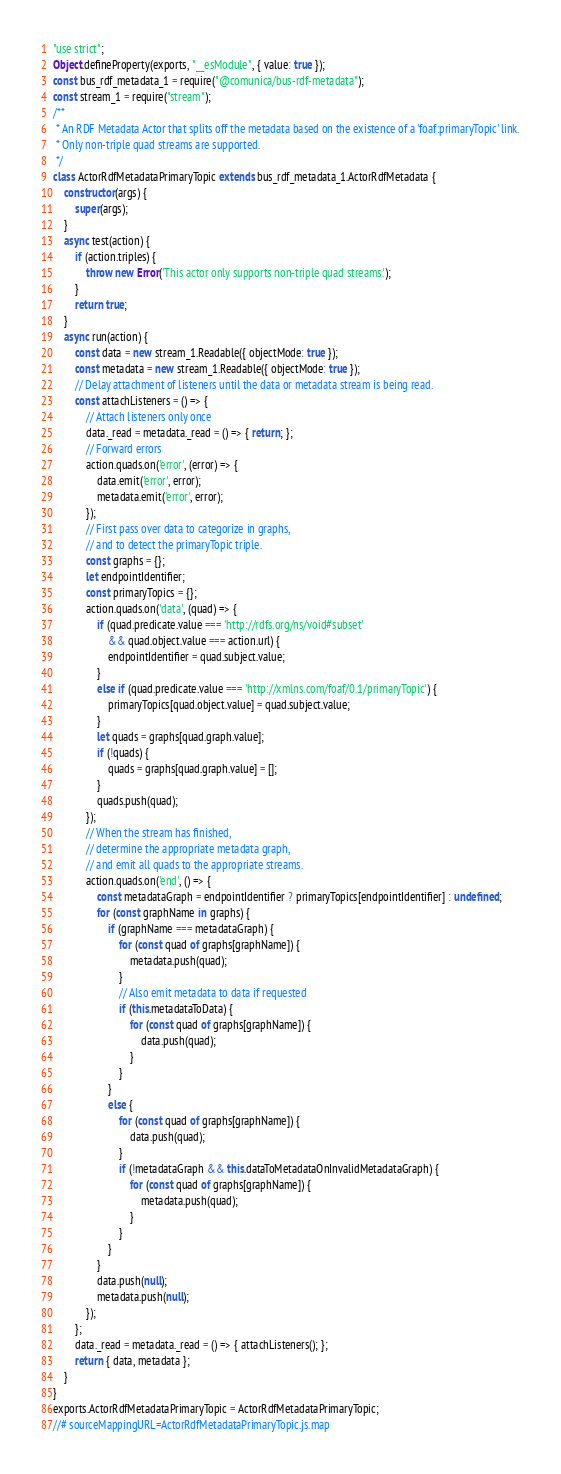<code> <loc_0><loc_0><loc_500><loc_500><_JavaScript_>"use strict";
Object.defineProperty(exports, "__esModule", { value: true });
const bus_rdf_metadata_1 = require("@comunica/bus-rdf-metadata");
const stream_1 = require("stream");
/**
 * An RDF Metadata Actor that splits off the metadata based on the existence of a 'foaf:primaryTopic' link.
 * Only non-triple quad streams are supported.
 */
class ActorRdfMetadataPrimaryTopic extends bus_rdf_metadata_1.ActorRdfMetadata {
    constructor(args) {
        super(args);
    }
    async test(action) {
        if (action.triples) {
            throw new Error('This actor only supports non-triple quad streams.');
        }
        return true;
    }
    async run(action) {
        const data = new stream_1.Readable({ objectMode: true });
        const metadata = new stream_1.Readable({ objectMode: true });
        // Delay attachment of listeners until the data or metadata stream is being read.
        const attachListeners = () => {
            // Attach listeners only once
            data._read = metadata._read = () => { return; };
            // Forward errors
            action.quads.on('error', (error) => {
                data.emit('error', error);
                metadata.emit('error', error);
            });
            // First pass over data to categorize in graphs,
            // and to detect the primaryTopic triple.
            const graphs = {};
            let endpointIdentifier;
            const primaryTopics = {};
            action.quads.on('data', (quad) => {
                if (quad.predicate.value === 'http://rdfs.org/ns/void#subset'
                    && quad.object.value === action.url) {
                    endpointIdentifier = quad.subject.value;
                }
                else if (quad.predicate.value === 'http://xmlns.com/foaf/0.1/primaryTopic') {
                    primaryTopics[quad.object.value] = quad.subject.value;
                }
                let quads = graphs[quad.graph.value];
                if (!quads) {
                    quads = graphs[quad.graph.value] = [];
                }
                quads.push(quad);
            });
            // When the stream has finished,
            // determine the appropriate metadata graph,
            // and emit all quads to the appropriate streams.
            action.quads.on('end', () => {
                const metadataGraph = endpointIdentifier ? primaryTopics[endpointIdentifier] : undefined;
                for (const graphName in graphs) {
                    if (graphName === metadataGraph) {
                        for (const quad of graphs[graphName]) {
                            metadata.push(quad);
                        }
                        // Also emit metadata to data if requested
                        if (this.metadataToData) {
                            for (const quad of graphs[graphName]) {
                                data.push(quad);
                            }
                        }
                    }
                    else {
                        for (const quad of graphs[graphName]) {
                            data.push(quad);
                        }
                        if (!metadataGraph && this.dataToMetadataOnInvalidMetadataGraph) {
                            for (const quad of graphs[graphName]) {
                                metadata.push(quad);
                            }
                        }
                    }
                }
                data.push(null);
                metadata.push(null);
            });
        };
        data._read = metadata._read = () => { attachListeners(); };
        return { data, metadata };
    }
}
exports.ActorRdfMetadataPrimaryTopic = ActorRdfMetadataPrimaryTopic;
//# sourceMappingURL=ActorRdfMetadataPrimaryTopic.js.map</code> 